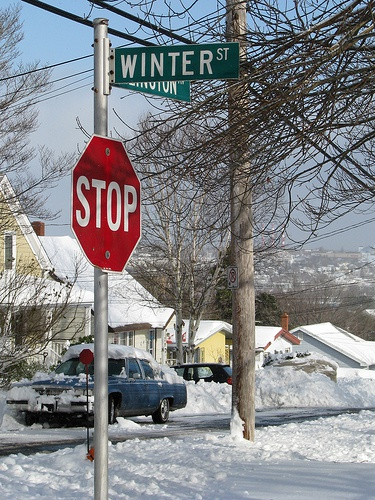Describe the objects in this image and their specific colors. I can see car in lightblue, black, darkgray, gray, and blue tones, stop sign in lightblue, brown, maroon, darkgray, and lightgray tones, and car in lightblue, black, gray, and darkgray tones in this image. 